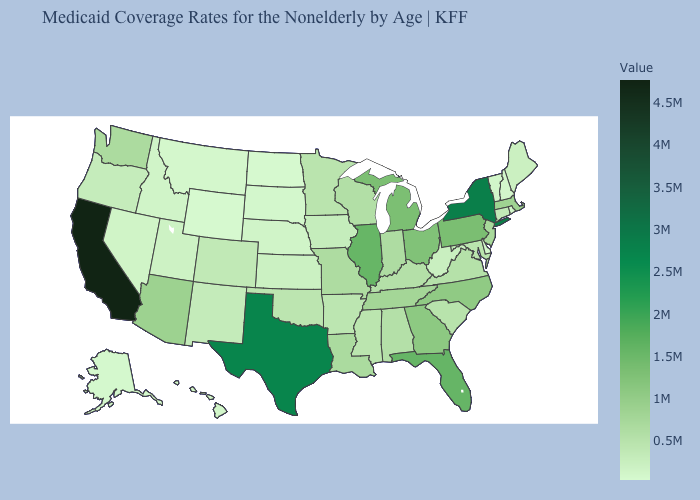Among the states that border Massachusetts , which have the lowest value?
Answer briefly. New Hampshire. Among the states that border South Dakota , does Minnesota have the highest value?
Concise answer only. Yes. Is the legend a continuous bar?
Keep it brief. Yes. Which states have the highest value in the USA?
Keep it brief. California. Does North Carolina have the lowest value in the South?
Keep it brief. No. Does North Dakota have the lowest value in the USA?
Answer briefly. Yes. Does Oklahoma have the lowest value in the South?
Give a very brief answer. No. 